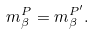Convert formula to latex. <formula><loc_0><loc_0><loc_500><loc_500>m ^ { P } _ { \beta } = m ^ { P ^ { \prime } } _ { \beta } .</formula> 